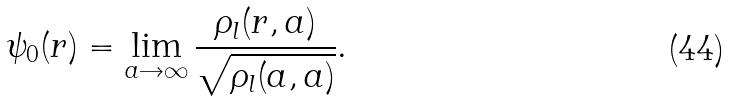<formula> <loc_0><loc_0><loc_500><loc_500>\psi _ { 0 } ( r ) = \lim _ { a \rightarrow \infty } \frac { \rho _ { l } ( r , a ) } { \sqrt { \rho _ { l } ( a , a ) } } .</formula> 